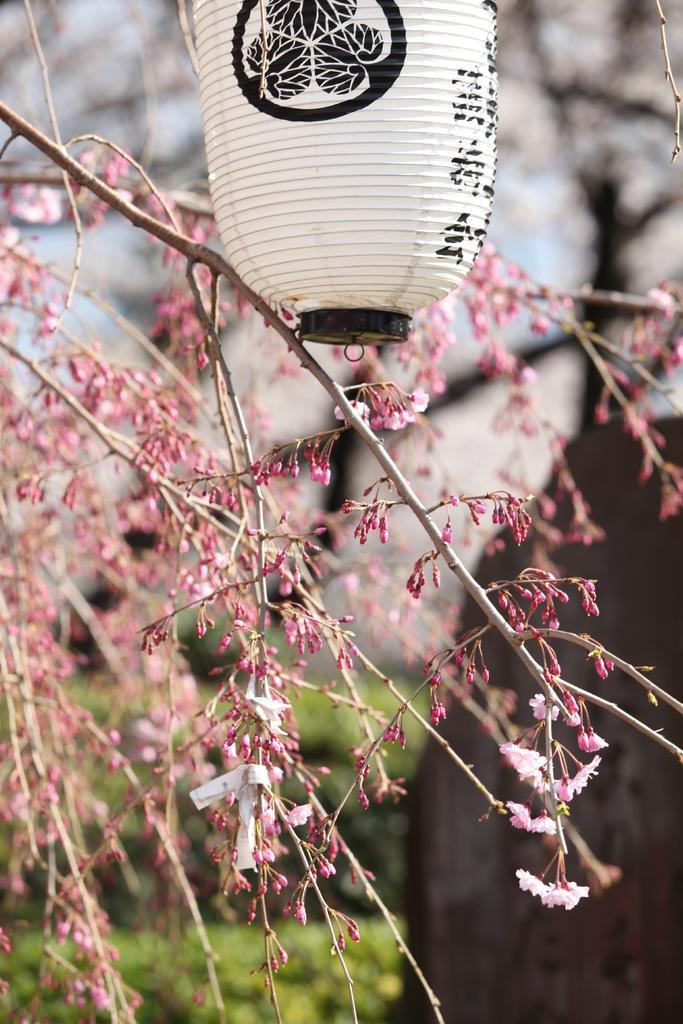Please provide a concise description of this image. In this image we can see the tree and also an object and the background is blurred with a house and also the plants. 